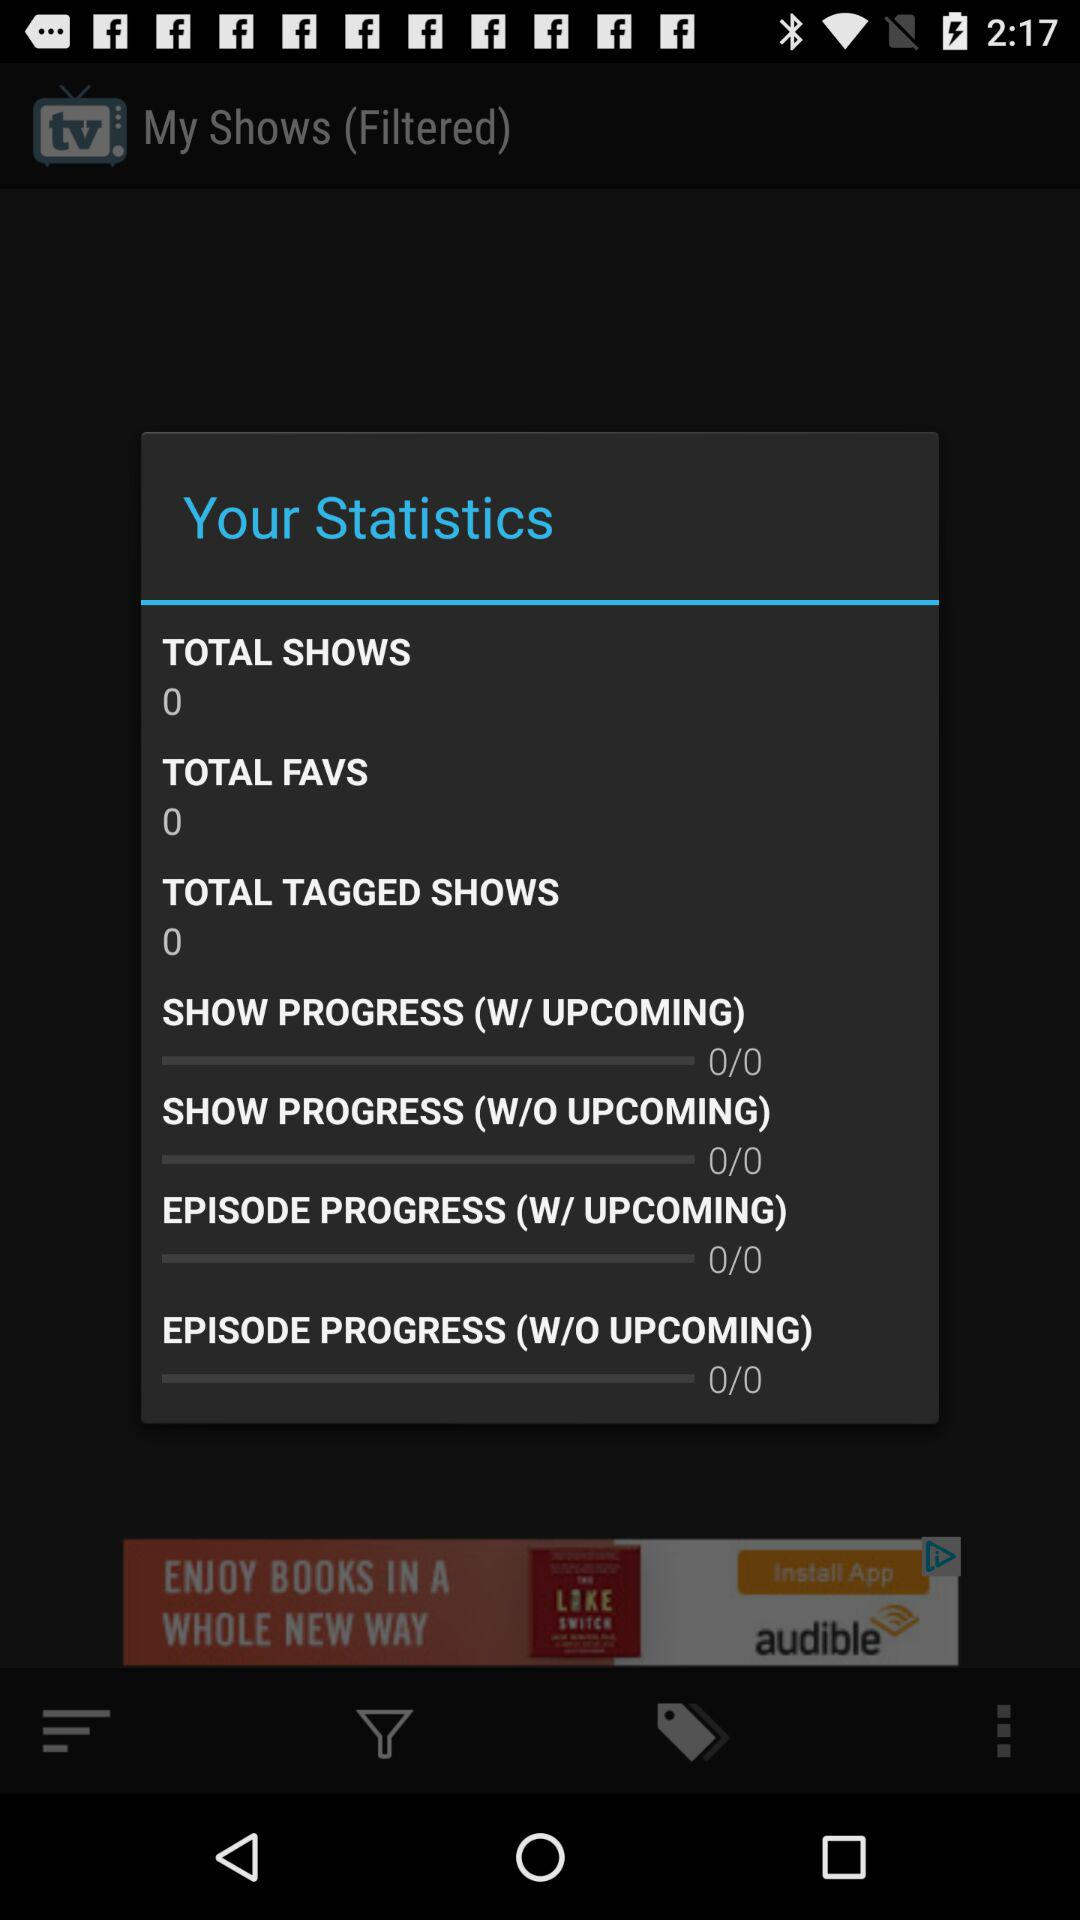How many shows in total are there? There are 0 shows in total. 